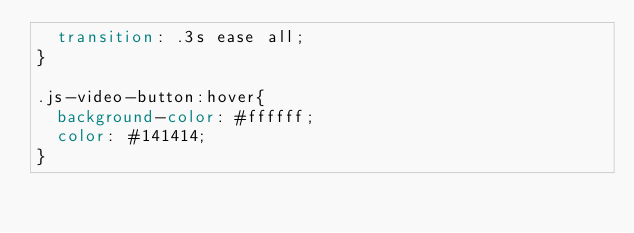<code> <loc_0><loc_0><loc_500><loc_500><_CSS_>  transition: .3s ease all;
}

.js-video-button:hover{
  background-color: #ffffff;
  color: #141414;
}</code> 